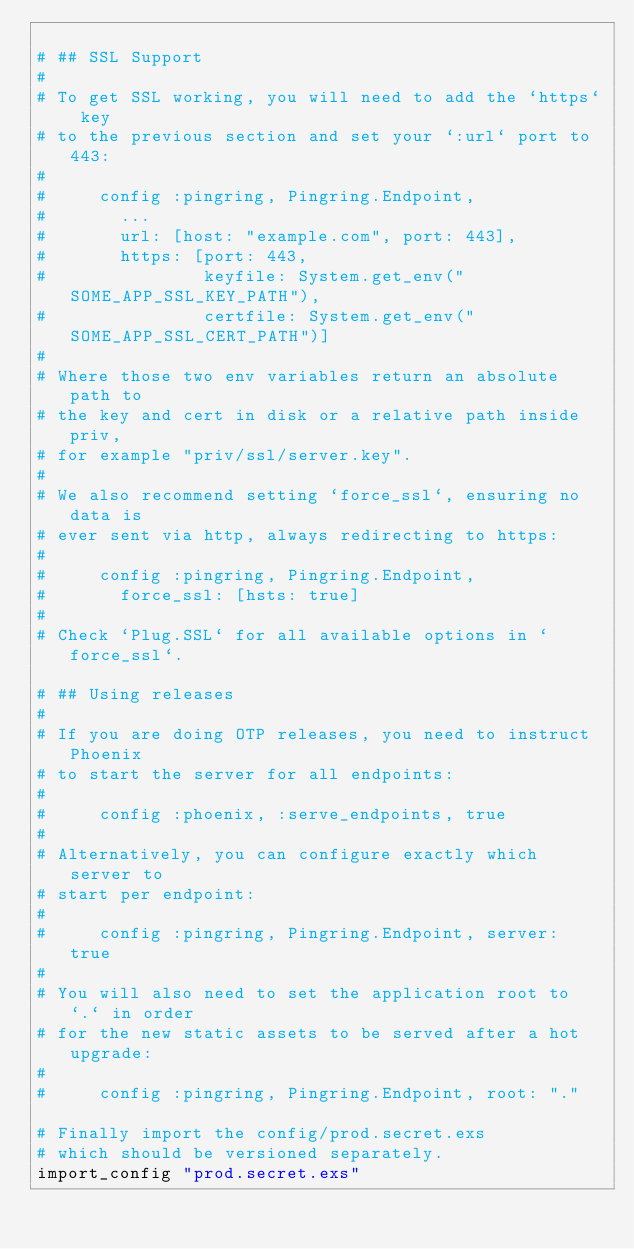<code> <loc_0><loc_0><loc_500><loc_500><_Elixir_>
# ## SSL Support
#
# To get SSL working, you will need to add the `https` key
# to the previous section and set your `:url` port to 443:
#
#     config :pingring, Pingring.Endpoint,
#       ...
#       url: [host: "example.com", port: 443],
#       https: [port: 443,
#               keyfile: System.get_env("SOME_APP_SSL_KEY_PATH"),
#               certfile: System.get_env("SOME_APP_SSL_CERT_PATH")]
#
# Where those two env variables return an absolute path to
# the key and cert in disk or a relative path inside priv,
# for example "priv/ssl/server.key".
#
# We also recommend setting `force_ssl`, ensuring no data is
# ever sent via http, always redirecting to https:
#
#     config :pingring, Pingring.Endpoint,
#       force_ssl: [hsts: true]
#
# Check `Plug.SSL` for all available options in `force_ssl`.

# ## Using releases
#
# If you are doing OTP releases, you need to instruct Phoenix
# to start the server for all endpoints:
#
#     config :phoenix, :serve_endpoints, true
#
# Alternatively, you can configure exactly which server to
# start per endpoint:
#
#     config :pingring, Pingring.Endpoint, server: true
#
# You will also need to set the application root to `.` in order
# for the new static assets to be served after a hot upgrade:
#
#     config :pingring, Pingring.Endpoint, root: "."

# Finally import the config/prod.secret.exs
# which should be versioned separately.
import_config "prod.secret.exs"
</code> 